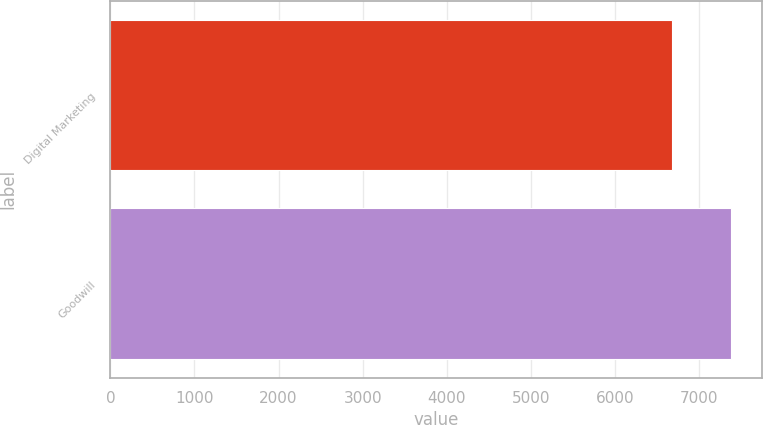Convert chart to OTSL. <chart><loc_0><loc_0><loc_500><loc_500><bar_chart><fcel>Digital Marketing<fcel>Goodwill<nl><fcel>6679<fcel>7380<nl></chart> 